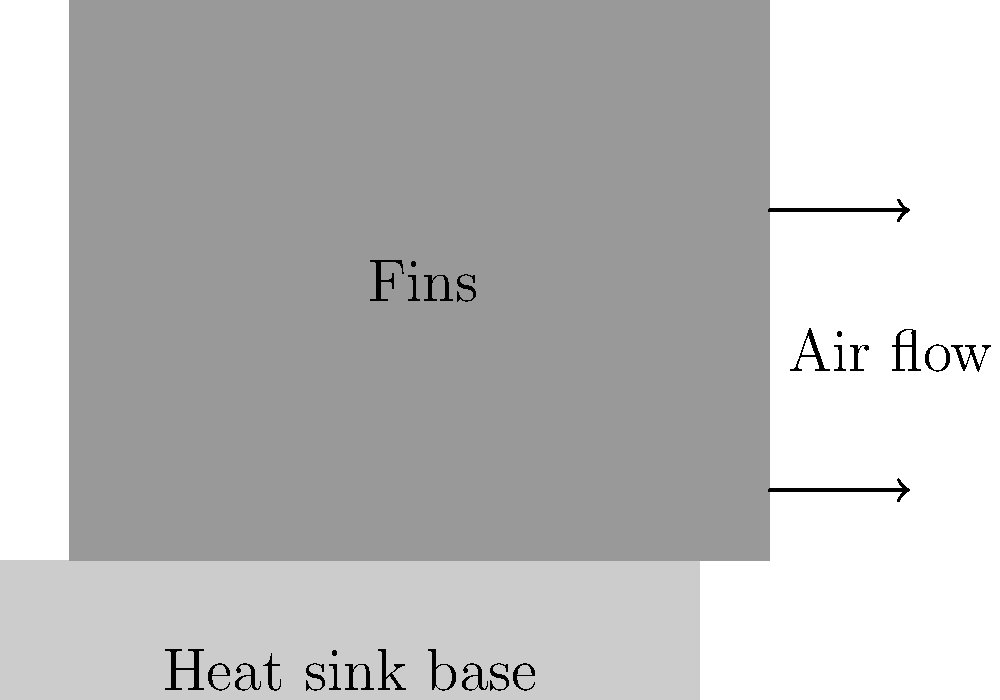In a finned heat sink design for a school's computer lab, you notice that the heat transfer rate is not meeting the required cooling performance. The heat sink has a base thickness of 10 mm and 5 equally spaced fins, each 80 mm tall and 20 mm thick. If the thermal conductivity of the material is 200 W/(m·K) and the temperature difference between the base and fin tip is 30°C, calculate the heat transfer rate through a single fin. How might this relate to ethical considerations in technology use in schools? To solve this problem, we'll use the equation for heat transfer rate through a single fin with a rectangular profile. The steps are as follows:

1. Identify the fin dimensions:
   Height (H) = 80 mm = 0.08 m
   Thickness (t) = 20 mm = 0.02 m
   
2. Calculate the perimeter (P) and cross-sectional area (Ac) of the fin:
   P = 2 * (thickness + width) = 2 * (0.02 + 0.02) = 0.08 m
   Ac = thickness * width = 0.02 * 0.02 = 0.0004 m²

3. Use the thermal conductivity (k) given:
   k = 200 W/(m·K)

4. Calculate the fin parameter (m):
   $m = \sqrt{\frac{hP}{kA_c}}$, where h is the convection heat transfer coefficient
   (For simplicity, we'll assume h ≈ 50 W/(m²·K) for forced air convection)
   
   $m = \sqrt{\frac{50 * 0.08}{200 * 0.0004}} = 31.62 \text{ m}^{-1}$

5. Calculate the heat transfer rate using the fin equation:
   $Q = \sqrt{hPkA_c} * \Delta T * \frac{\sinh(mH) + (h/mk)\cosh(mH)}{\cosh(mH) + (h/mk)\sinh(mH)}$

   Where ΔT is the temperature difference (30°C)

6. Substitute the values and solve:
   $Q = \sqrt{50 * 0.08 * 200 * 0.0004} * 30 * \frac{\sinh(31.62 * 0.08) + (50/(31.62*200))\cosh(31.62 * 0.08)}{\cosh(31.62 * 0.08) + (50/(31.62*200))\sinh(31.62 * 0.08)}$

7. Calculate the final result:
   Q ≈ 11.2 W per fin

This result relates to ethical considerations in technology use in schools by highlighting the importance of energy efficiency and responsible resource management. Proper thermal management in computer labs can reduce energy consumption, extend equipment lifespan, and create a more comfortable learning environment for students.
Answer: 11.2 W per fin 